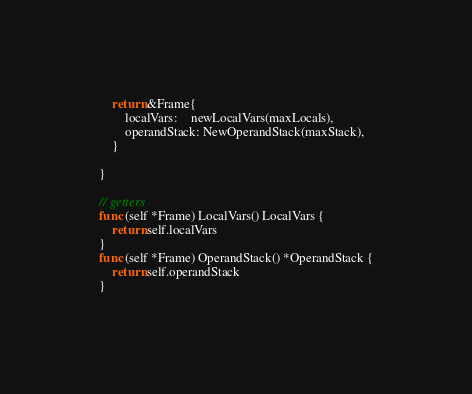<code> <loc_0><loc_0><loc_500><loc_500><_Go_>	return &Frame{
		localVars:    newLocalVars(maxLocals),
		operandStack: NewOperandStack(maxStack),
	}

}

// getters
func (self *Frame) LocalVars() LocalVars {
	return self.localVars
}
func (self *Frame) OperandStack() *OperandStack {
	return self.operandStack
}
</code> 